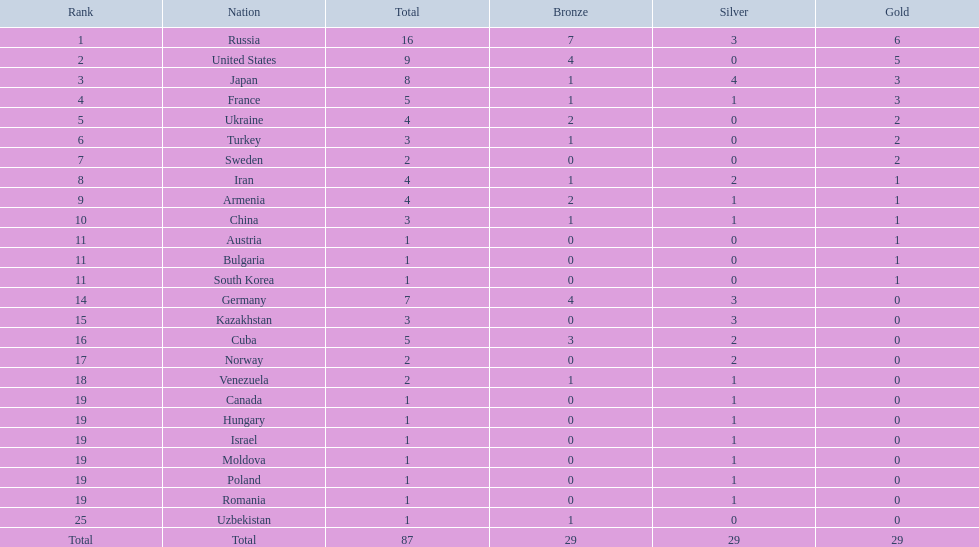How many countries competed? Israel. How many total medals did russia win? 16. What country won only 1 medal? Uzbekistan. 